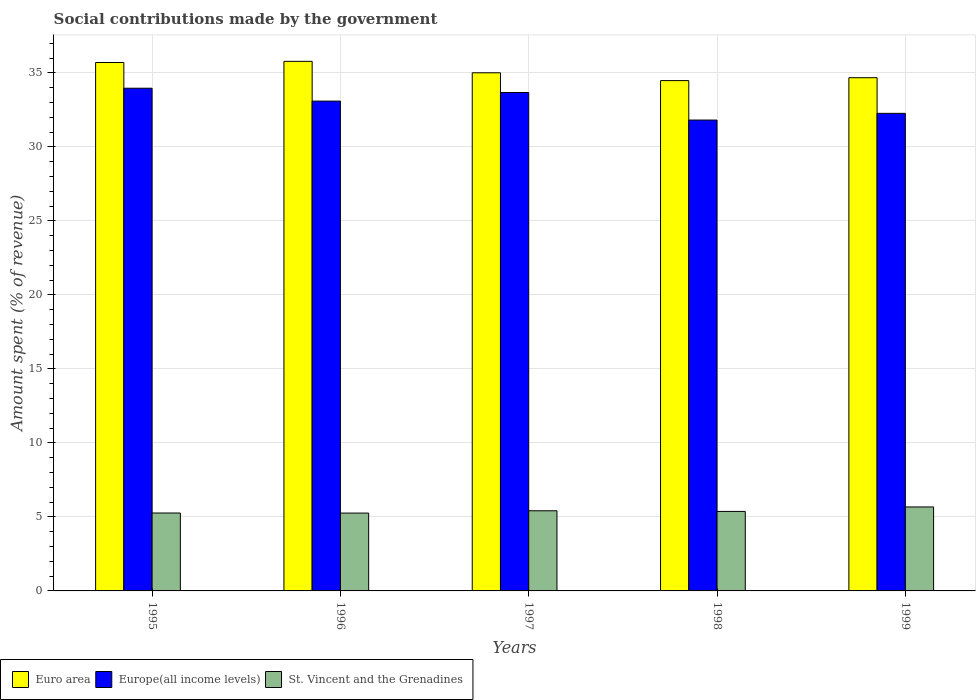How many groups of bars are there?
Provide a short and direct response. 5. Are the number of bars on each tick of the X-axis equal?
Your answer should be very brief. Yes. How many bars are there on the 5th tick from the left?
Make the answer very short. 3. What is the amount spent (in %) on social contributions in St. Vincent and the Grenadines in 1995?
Offer a very short reply. 5.26. Across all years, what is the maximum amount spent (in %) on social contributions in Europe(all income levels)?
Give a very brief answer. 33.96. Across all years, what is the minimum amount spent (in %) on social contributions in St. Vincent and the Grenadines?
Give a very brief answer. 5.26. In which year was the amount spent (in %) on social contributions in Europe(all income levels) maximum?
Your answer should be very brief. 1995. In which year was the amount spent (in %) on social contributions in St. Vincent and the Grenadines minimum?
Make the answer very short. 1996. What is the total amount spent (in %) on social contributions in St. Vincent and the Grenadines in the graph?
Keep it short and to the point. 26.98. What is the difference between the amount spent (in %) on social contributions in Europe(all income levels) in 1995 and that in 1996?
Your response must be concise. 0.87. What is the difference between the amount spent (in %) on social contributions in Europe(all income levels) in 1996 and the amount spent (in %) on social contributions in Euro area in 1995?
Your answer should be compact. -2.61. What is the average amount spent (in %) on social contributions in St. Vincent and the Grenadines per year?
Offer a very short reply. 5.4. In the year 1997, what is the difference between the amount spent (in %) on social contributions in St. Vincent and the Grenadines and amount spent (in %) on social contributions in Europe(all income levels)?
Ensure brevity in your answer.  -28.25. In how many years, is the amount spent (in %) on social contributions in Europe(all income levels) greater than 16 %?
Give a very brief answer. 5. What is the ratio of the amount spent (in %) on social contributions in Euro area in 1997 to that in 1999?
Give a very brief answer. 1.01. Is the difference between the amount spent (in %) on social contributions in St. Vincent and the Grenadines in 1995 and 1996 greater than the difference between the amount spent (in %) on social contributions in Europe(all income levels) in 1995 and 1996?
Your answer should be compact. No. What is the difference between the highest and the second highest amount spent (in %) on social contributions in Euro area?
Offer a very short reply. 0.08. What is the difference between the highest and the lowest amount spent (in %) on social contributions in St. Vincent and the Grenadines?
Your answer should be very brief. 0.41. Is the sum of the amount spent (in %) on social contributions in St. Vincent and the Grenadines in 1995 and 1999 greater than the maximum amount spent (in %) on social contributions in Europe(all income levels) across all years?
Keep it short and to the point. No. What does the 1st bar from the right in 1998 represents?
Your response must be concise. St. Vincent and the Grenadines. Is it the case that in every year, the sum of the amount spent (in %) on social contributions in St. Vincent and the Grenadines and amount spent (in %) on social contributions in Europe(all income levels) is greater than the amount spent (in %) on social contributions in Euro area?
Provide a short and direct response. Yes. How many bars are there?
Keep it short and to the point. 15. Are all the bars in the graph horizontal?
Give a very brief answer. No. What is the difference between two consecutive major ticks on the Y-axis?
Provide a short and direct response. 5. Does the graph contain any zero values?
Your answer should be compact. No. What is the title of the graph?
Make the answer very short. Social contributions made by the government. What is the label or title of the Y-axis?
Your response must be concise. Amount spent (% of revenue). What is the Amount spent (% of revenue) in Euro area in 1995?
Keep it short and to the point. 35.7. What is the Amount spent (% of revenue) in Europe(all income levels) in 1995?
Make the answer very short. 33.96. What is the Amount spent (% of revenue) in St. Vincent and the Grenadines in 1995?
Offer a very short reply. 5.26. What is the Amount spent (% of revenue) of Euro area in 1996?
Ensure brevity in your answer.  35.77. What is the Amount spent (% of revenue) in Europe(all income levels) in 1996?
Your answer should be very brief. 33.09. What is the Amount spent (% of revenue) in St. Vincent and the Grenadines in 1996?
Offer a very short reply. 5.26. What is the Amount spent (% of revenue) in Euro area in 1997?
Your response must be concise. 35. What is the Amount spent (% of revenue) in Europe(all income levels) in 1997?
Offer a terse response. 33.67. What is the Amount spent (% of revenue) in St. Vincent and the Grenadines in 1997?
Give a very brief answer. 5.41. What is the Amount spent (% of revenue) of Euro area in 1998?
Keep it short and to the point. 34.47. What is the Amount spent (% of revenue) in Europe(all income levels) in 1998?
Ensure brevity in your answer.  31.81. What is the Amount spent (% of revenue) of St. Vincent and the Grenadines in 1998?
Offer a very short reply. 5.37. What is the Amount spent (% of revenue) of Euro area in 1999?
Your answer should be very brief. 34.67. What is the Amount spent (% of revenue) in Europe(all income levels) in 1999?
Ensure brevity in your answer.  32.26. What is the Amount spent (% of revenue) of St. Vincent and the Grenadines in 1999?
Ensure brevity in your answer.  5.67. Across all years, what is the maximum Amount spent (% of revenue) of Euro area?
Make the answer very short. 35.77. Across all years, what is the maximum Amount spent (% of revenue) of Europe(all income levels)?
Keep it short and to the point. 33.96. Across all years, what is the maximum Amount spent (% of revenue) of St. Vincent and the Grenadines?
Ensure brevity in your answer.  5.67. Across all years, what is the minimum Amount spent (% of revenue) of Euro area?
Keep it short and to the point. 34.47. Across all years, what is the minimum Amount spent (% of revenue) of Europe(all income levels)?
Make the answer very short. 31.81. Across all years, what is the minimum Amount spent (% of revenue) in St. Vincent and the Grenadines?
Your answer should be very brief. 5.26. What is the total Amount spent (% of revenue) in Euro area in the graph?
Keep it short and to the point. 175.61. What is the total Amount spent (% of revenue) of Europe(all income levels) in the graph?
Your response must be concise. 164.79. What is the total Amount spent (% of revenue) in St. Vincent and the Grenadines in the graph?
Your answer should be compact. 26.98. What is the difference between the Amount spent (% of revenue) in Euro area in 1995 and that in 1996?
Give a very brief answer. -0.08. What is the difference between the Amount spent (% of revenue) in Europe(all income levels) in 1995 and that in 1996?
Make the answer very short. 0.87. What is the difference between the Amount spent (% of revenue) of St. Vincent and the Grenadines in 1995 and that in 1996?
Offer a very short reply. 0. What is the difference between the Amount spent (% of revenue) in Euro area in 1995 and that in 1997?
Provide a short and direct response. 0.69. What is the difference between the Amount spent (% of revenue) in Europe(all income levels) in 1995 and that in 1997?
Ensure brevity in your answer.  0.29. What is the difference between the Amount spent (% of revenue) in St. Vincent and the Grenadines in 1995 and that in 1997?
Your answer should be compact. -0.15. What is the difference between the Amount spent (% of revenue) in Euro area in 1995 and that in 1998?
Keep it short and to the point. 1.22. What is the difference between the Amount spent (% of revenue) of Europe(all income levels) in 1995 and that in 1998?
Your response must be concise. 2.15. What is the difference between the Amount spent (% of revenue) of St. Vincent and the Grenadines in 1995 and that in 1998?
Offer a terse response. -0.11. What is the difference between the Amount spent (% of revenue) of Euro area in 1995 and that in 1999?
Offer a very short reply. 1.03. What is the difference between the Amount spent (% of revenue) in Europe(all income levels) in 1995 and that in 1999?
Make the answer very short. 1.7. What is the difference between the Amount spent (% of revenue) in St. Vincent and the Grenadines in 1995 and that in 1999?
Keep it short and to the point. -0.41. What is the difference between the Amount spent (% of revenue) of Euro area in 1996 and that in 1997?
Ensure brevity in your answer.  0.77. What is the difference between the Amount spent (% of revenue) of Europe(all income levels) in 1996 and that in 1997?
Give a very brief answer. -0.58. What is the difference between the Amount spent (% of revenue) in St. Vincent and the Grenadines in 1996 and that in 1997?
Your answer should be compact. -0.16. What is the difference between the Amount spent (% of revenue) in Euro area in 1996 and that in 1998?
Keep it short and to the point. 1.3. What is the difference between the Amount spent (% of revenue) of Europe(all income levels) in 1996 and that in 1998?
Your answer should be very brief. 1.28. What is the difference between the Amount spent (% of revenue) in St. Vincent and the Grenadines in 1996 and that in 1998?
Ensure brevity in your answer.  -0.11. What is the difference between the Amount spent (% of revenue) in Euro area in 1996 and that in 1999?
Offer a terse response. 1.11. What is the difference between the Amount spent (% of revenue) in Europe(all income levels) in 1996 and that in 1999?
Your response must be concise. 0.83. What is the difference between the Amount spent (% of revenue) of St. Vincent and the Grenadines in 1996 and that in 1999?
Your answer should be compact. -0.41. What is the difference between the Amount spent (% of revenue) in Euro area in 1997 and that in 1998?
Your answer should be very brief. 0.53. What is the difference between the Amount spent (% of revenue) in Europe(all income levels) in 1997 and that in 1998?
Offer a terse response. 1.86. What is the difference between the Amount spent (% of revenue) of St. Vincent and the Grenadines in 1997 and that in 1998?
Provide a short and direct response. 0.04. What is the difference between the Amount spent (% of revenue) of Euro area in 1997 and that in 1999?
Offer a terse response. 0.33. What is the difference between the Amount spent (% of revenue) in Europe(all income levels) in 1997 and that in 1999?
Keep it short and to the point. 1.41. What is the difference between the Amount spent (% of revenue) in St. Vincent and the Grenadines in 1997 and that in 1999?
Ensure brevity in your answer.  -0.26. What is the difference between the Amount spent (% of revenue) in Euro area in 1998 and that in 1999?
Ensure brevity in your answer.  -0.2. What is the difference between the Amount spent (% of revenue) of Europe(all income levels) in 1998 and that in 1999?
Keep it short and to the point. -0.45. What is the difference between the Amount spent (% of revenue) in St. Vincent and the Grenadines in 1998 and that in 1999?
Your answer should be very brief. -0.3. What is the difference between the Amount spent (% of revenue) in Euro area in 1995 and the Amount spent (% of revenue) in Europe(all income levels) in 1996?
Give a very brief answer. 2.61. What is the difference between the Amount spent (% of revenue) in Euro area in 1995 and the Amount spent (% of revenue) in St. Vincent and the Grenadines in 1996?
Offer a terse response. 30.44. What is the difference between the Amount spent (% of revenue) in Europe(all income levels) in 1995 and the Amount spent (% of revenue) in St. Vincent and the Grenadines in 1996?
Your answer should be compact. 28.7. What is the difference between the Amount spent (% of revenue) in Euro area in 1995 and the Amount spent (% of revenue) in Europe(all income levels) in 1997?
Offer a terse response. 2.03. What is the difference between the Amount spent (% of revenue) in Euro area in 1995 and the Amount spent (% of revenue) in St. Vincent and the Grenadines in 1997?
Ensure brevity in your answer.  30.28. What is the difference between the Amount spent (% of revenue) of Europe(all income levels) in 1995 and the Amount spent (% of revenue) of St. Vincent and the Grenadines in 1997?
Provide a succinct answer. 28.55. What is the difference between the Amount spent (% of revenue) in Euro area in 1995 and the Amount spent (% of revenue) in Europe(all income levels) in 1998?
Your answer should be very brief. 3.89. What is the difference between the Amount spent (% of revenue) in Euro area in 1995 and the Amount spent (% of revenue) in St. Vincent and the Grenadines in 1998?
Provide a succinct answer. 30.32. What is the difference between the Amount spent (% of revenue) of Europe(all income levels) in 1995 and the Amount spent (% of revenue) of St. Vincent and the Grenadines in 1998?
Offer a very short reply. 28.59. What is the difference between the Amount spent (% of revenue) in Euro area in 1995 and the Amount spent (% of revenue) in Europe(all income levels) in 1999?
Give a very brief answer. 3.43. What is the difference between the Amount spent (% of revenue) of Euro area in 1995 and the Amount spent (% of revenue) of St. Vincent and the Grenadines in 1999?
Provide a short and direct response. 30.02. What is the difference between the Amount spent (% of revenue) in Europe(all income levels) in 1995 and the Amount spent (% of revenue) in St. Vincent and the Grenadines in 1999?
Your response must be concise. 28.29. What is the difference between the Amount spent (% of revenue) of Euro area in 1996 and the Amount spent (% of revenue) of Europe(all income levels) in 1997?
Make the answer very short. 2.11. What is the difference between the Amount spent (% of revenue) of Euro area in 1996 and the Amount spent (% of revenue) of St. Vincent and the Grenadines in 1997?
Your response must be concise. 30.36. What is the difference between the Amount spent (% of revenue) in Europe(all income levels) in 1996 and the Amount spent (% of revenue) in St. Vincent and the Grenadines in 1997?
Your answer should be very brief. 27.68. What is the difference between the Amount spent (% of revenue) in Euro area in 1996 and the Amount spent (% of revenue) in Europe(all income levels) in 1998?
Your answer should be very brief. 3.97. What is the difference between the Amount spent (% of revenue) of Euro area in 1996 and the Amount spent (% of revenue) of St. Vincent and the Grenadines in 1998?
Provide a short and direct response. 30.4. What is the difference between the Amount spent (% of revenue) of Europe(all income levels) in 1996 and the Amount spent (% of revenue) of St. Vincent and the Grenadines in 1998?
Give a very brief answer. 27.72. What is the difference between the Amount spent (% of revenue) of Euro area in 1996 and the Amount spent (% of revenue) of Europe(all income levels) in 1999?
Your answer should be very brief. 3.51. What is the difference between the Amount spent (% of revenue) of Euro area in 1996 and the Amount spent (% of revenue) of St. Vincent and the Grenadines in 1999?
Provide a short and direct response. 30.1. What is the difference between the Amount spent (% of revenue) in Europe(all income levels) in 1996 and the Amount spent (% of revenue) in St. Vincent and the Grenadines in 1999?
Offer a very short reply. 27.42. What is the difference between the Amount spent (% of revenue) in Euro area in 1997 and the Amount spent (% of revenue) in Europe(all income levels) in 1998?
Ensure brevity in your answer.  3.19. What is the difference between the Amount spent (% of revenue) of Euro area in 1997 and the Amount spent (% of revenue) of St. Vincent and the Grenadines in 1998?
Your answer should be compact. 29.63. What is the difference between the Amount spent (% of revenue) of Europe(all income levels) in 1997 and the Amount spent (% of revenue) of St. Vincent and the Grenadines in 1998?
Your answer should be compact. 28.3. What is the difference between the Amount spent (% of revenue) in Euro area in 1997 and the Amount spent (% of revenue) in Europe(all income levels) in 1999?
Provide a short and direct response. 2.74. What is the difference between the Amount spent (% of revenue) in Euro area in 1997 and the Amount spent (% of revenue) in St. Vincent and the Grenadines in 1999?
Give a very brief answer. 29.33. What is the difference between the Amount spent (% of revenue) of Europe(all income levels) in 1997 and the Amount spent (% of revenue) of St. Vincent and the Grenadines in 1999?
Provide a short and direct response. 28. What is the difference between the Amount spent (% of revenue) in Euro area in 1998 and the Amount spent (% of revenue) in Europe(all income levels) in 1999?
Your answer should be compact. 2.21. What is the difference between the Amount spent (% of revenue) in Euro area in 1998 and the Amount spent (% of revenue) in St. Vincent and the Grenadines in 1999?
Provide a succinct answer. 28.8. What is the difference between the Amount spent (% of revenue) of Europe(all income levels) in 1998 and the Amount spent (% of revenue) of St. Vincent and the Grenadines in 1999?
Your response must be concise. 26.14. What is the average Amount spent (% of revenue) in Euro area per year?
Keep it short and to the point. 35.12. What is the average Amount spent (% of revenue) of Europe(all income levels) per year?
Provide a succinct answer. 32.96. What is the average Amount spent (% of revenue) of St. Vincent and the Grenadines per year?
Give a very brief answer. 5.4. In the year 1995, what is the difference between the Amount spent (% of revenue) of Euro area and Amount spent (% of revenue) of Europe(all income levels)?
Ensure brevity in your answer.  1.74. In the year 1995, what is the difference between the Amount spent (% of revenue) of Euro area and Amount spent (% of revenue) of St. Vincent and the Grenadines?
Your response must be concise. 30.43. In the year 1995, what is the difference between the Amount spent (% of revenue) of Europe(all income levels) and Amount spent (% of revenue) of St. Vincent and the Grenadines?
Make the answer very short. 28.7. In the year 1996, what is the difference between the Amount spent (% of revenue) of Euro area and Amount spent (% of revenue) of Europe(all income levels)?
Your response must be concise. 2.69. In the year 1996, what is the difference between the Amount spent (% of revenue) of Euro area and Amount spent (% of revenue) of St. Vincent and the Grenadines?
Ensure brevity in your answer.  30.52. In the year 1996, what is the difference between the Amount spent (% of revenue) in Europe(all income levels) and Amount spent (% of revenue) in St. Vincent and the Grenadines?
Provide a short and direct response. 27.83. In the year 1997, what is the difference between the Amount spent (% of revenue) in Euro area and Amount spent (% of revenue) in Europe(all income levels)?
Your answer should be very brief. 1.33. In the year 1997, what is the difference between the Amount spent (% of revenue) of Euro area and Amount spent (% of revenue) of St. Vincent and the Grenadines?
Your answer should be very brief. 29.59. In the year 1997, what is the difference between the Amount spent (% of revenue) of Europe(all income levels) and Amount spent (% of revenue) of St. Vincent and the Grenadines?
Your response must be concise. 28.25. In the year 1998, what is the difference between the Amount spent (% of revenue) of Euro area and Amount spent (% of revenue) of Europe(all income levels)?
Your response must be concise. 2.67. In the year 1998, what is the difference between the Amount spent (% of revenue) in Euro area and Amount spent (% of revenue) in St. Vincent and the Grenadines?
Offer a terse response. 29.1. In the year 1998, what is the difference between the Amount spent (% of revenue) of Europe(all income levels) and Amount spent (% of revenue) of St. Vincent and the Grenadines?
Your answer should be compact. 26.44. In the year 1999, what is the difference between the Amount spent (% of revenue) in Euro area and Amount spent (% of revenue) in Europe(all income levels)?
Keep it short and to the point. 2.41. In the year 1999, what is the difference between the Amount spent (% of revenue) in Euro area and Amount spent (% of revenue) in St. Vincent and the Grenadines?
Your answer should be compact. 29. In the year 1999, what is the difference between the Amount spent (% of revenue) in Europe(all income levels) and Amount spent (% of revenue) in St. Vincent and the Grenadines?
Your response must be concise. 26.59. What is the ratio of the Amount spent (% of revenue) in Euro area in 1995 to that in 1996?
Your answer should be compact. 1. What is the ratio of the Amount spent (% of revenue) of Europe(all income levels) in 1995 to that in 1996?
Offer a very short reply. 1.03. What is the ratio of the Amount spent (% of revenue) in St. Vincent and the Grenadines in 1995 to that in 1996?
Give a very brief answer. 1. What is the ratio of the Amount spent (% of revenue) in Euro area in 1995 to that in 1997?
Your response must be concise. 1.02. What is the ratio of the Amount spent (% of revenue) in Europe(all income levels) in 1995 to that in 1997?
Provide a short and direct response. 1.01. What is the ratio of the Amount spent (% of revenue) in St. Vincent and the Grenadines in 1995 to that in 1997?
Make the answer very short. 0.97. What is the ratio of the Amount spent (% of revenue) in Euro area in 1995 to that in 1998?
Keep it short and to the point. 1.04. What is the ratio of the Amount spent (% of revenue) of Europe(all income levels) in 1995 to that in 1998?
Offer a very short reply. 1.07. What is the ratio of the Amount spent (% of revenue) of St. Vincent and the Grenadines in 1995 to that in 1998?
Offer a very short reply. 0.98. What is the ratio of the Amount spent (% of revenue) of Euro area in 1995 to that in 1999?
Provide a succinct answer. 1.03. What is the ratio of the Amount spent (% of revenue) in Europe(all income levels) in 1995 to that in 1999?
Keep it short and to the point. 1.05. What is the ratio of the Amount spent (% of revenue) in St. Vincent and the Grenadines in 1995 to that in 1999?
Give a very brief answer. 0.93. What is the ratio of the Amount spent (% of revenue) of Euro area in 1996 to that in 1997?
Provide a succinct answer. 1.02. What is the ratio of the Amount spent (% of revenue) of Europe(all income levels) in 1996 to that in 1997?
Keep it short and to the point. 0.98. What is the ratio of the Amount spent (% of revenue) of St. Vincent and the Grenadines in 1996 to that in 1997?
Provide a succinct answer. 0.97. What is the ratio of the Amount spent (% of revenue) of Euro area in 1996 to that in 1998?
Provide a succinct answer. 1.04. What is the ratio of the Amount spent (% of revenue) in Europe(all income levels) in 1996 to that in 1998?
Your answer should be compact. 1.04. What is the ratio of the Amount spent (% of revenue) in St. Vincent and the Grenadines in 1996 to that in 1998?
Make the answer very short. 0.98. What is the ratio of the Amount spent (% of revenue) in Euro area in 1996 to that in 1999?
Your answer should be compact. 1.03. What is the ratio of the Amount spent (% of revenue) in Europe(all income levels) in 1996 to that in 1999?
Your answer should be compact. 1.03. What is the ratio of the Amount spent (% of revenue) of St. Vincent and the Grenadines in 1996 to that in 1999?
Your answer should be compact. 0.93. What is the ratio of the Amount spent (% of revenue) in Euro area in 1997 to that in 1998?
Give a very brief answer. 1.02. What is the ratio of the Amount spent (% of revenue) of Europe(all income levels) in 1997 to that in 1998?
Your answer should be very brief. 1.06. What is the ratio of the Amount spent (% of revenue) of St. Vincent and the Grenadines in 1997 to that in 1998?
Your answer should be very brief. 1.01. What is the ratio of the Amount spent (% of revenue) in Euro area in 1997 to that in 1999?
Provide a short and direct response. 1.01. What is the ratio of the Amount spent (% of revenue) of Europe(all income levels) in 1997 to that in 1999?
Make the answer very short. 1.04. What is the ratio of the Amount spent (% of revenue) of St. Vincent and the Grenadines in 1997 to that in 1999?
Your response must be concise. 0.95. What is the ratio of the Amount spent (% of revenue) in Europe(all income levels) in 1998 to that in 1999?
Ensure brevity in your answer.  0.99. What is the ratio of the Amount spent (% of revenue) of St. Vincent and the Grenadines in 1998 to that in 1999?
Offer a very short reply. 0.95. What is the difference between the highest and the second highest Amount spent (% of revenue) in Euro area?
Provide a succinct answer. 0.08. What is the difference between the highest and the second highest Amount spent (% of revenue) in Europe(all income levels)?
Your response must be concise. 0.29. What is the difference between the highest and the second highest Amount spent (% of revenue) in St. Vincent and the Grenadines?
Ensure brevity in your answer.  0.26. What is the difference between the highest and the lowest Amount spent (% of revenue) of Euro area?
Offer a terse response. 1.3. What is the difference between the highest and the lowest Amount spent (% of revenue) of Europe(all income levels)?
Make the answer very short. 2.15. What is the difference between the highest and the lowest Amount spent (% of revenue) of St. Vincent and the Grenadines?
Provide a short and direct response. 0.41. 